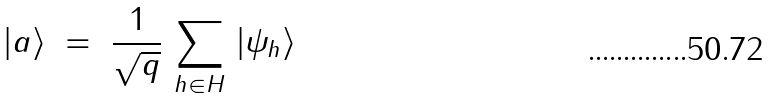Convert formula to latex. <formula><loc_0><loc_0><loc_500><loc_500>| a \rangle \ = \ \frac { 1 } { \sqrt { q } } \, \sum _ { h \in H } \, | \psi _ { h } \rangle</formula> 